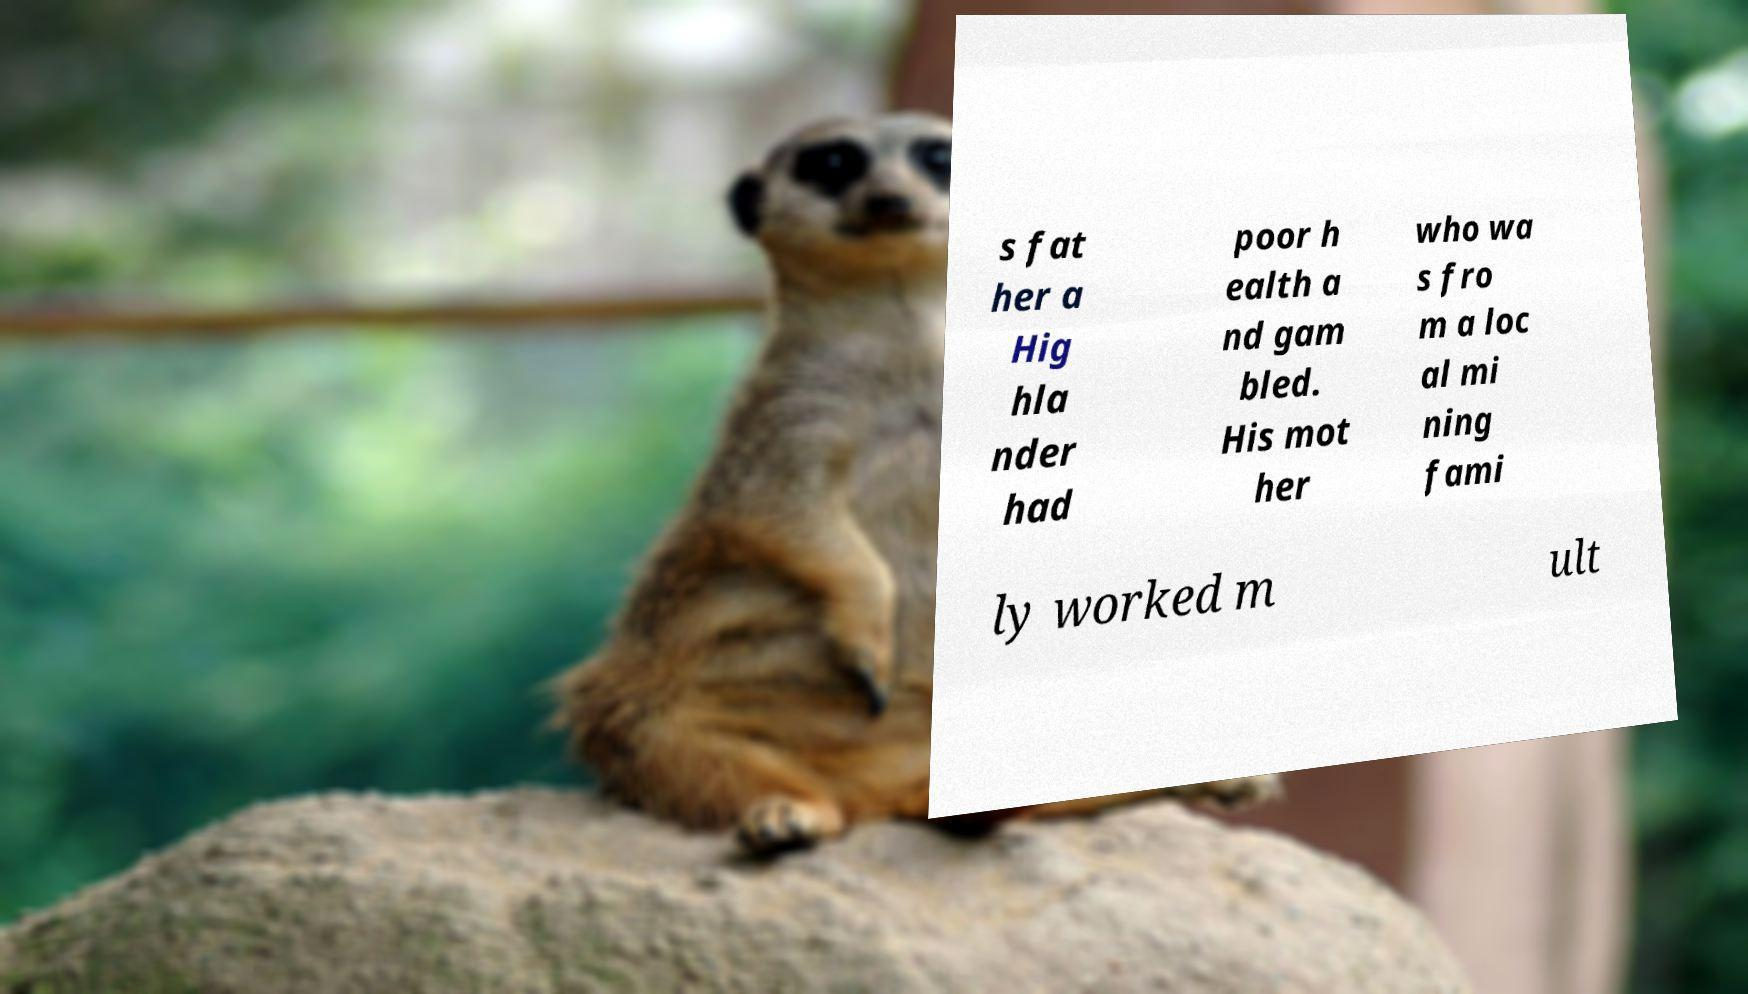I need the written content from this picture converted into text. Can you do that? s fat her a Hig hla nder had poor h ealth a nd gam bled. His mot her who wa s fro m a loc al mi ning fami ly worked m ult 